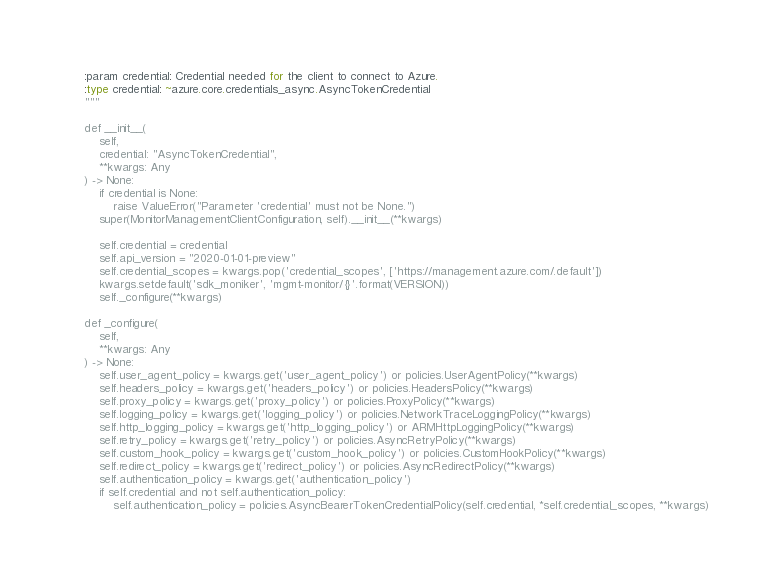<code> <loc_0><loc_0><loc_500><loc_500><_Python_>
    :param credential: Credential needed for the client to connect to Azure.
    :type credential: ~azure.core.credentials_async.AsyncTokenCredential
    """

    def __init__(
        self,
        credential: "AsyncTokenCredential",
        **kwargs: Any
    ) -> None:
        if credential is None:
            raise ValueError("Parameter 'credential' must not be None.")
        super(MonitorManagementClientConfiguration, self).__init__(**kwargs)

        self.credential = credential
        self.api_version = "2020-01-01-preview"
        self.credential_scopes = kwargs.pop('credential_scopes', ['https://management.azure.com/.default'])
        kwargs.setdefault('sdk_moniker', 'mgmt-monitor/{}'.format(VERSION))
        self._configure(**kwargs)

    def _configure(
        self,
        **kwargs: Any
    ) -> None:
        self.user_agent_policy = kwargs.get('user_agent_policy') or policies.UserAgentPolicy(**kwargs)
        self.headers_policy = kwargs.get('headers_policy') or policies.HeadersPolicy(**kwargs)
        self.proxy_policy = kwargs.get('proxy_policy') or policies.ProxyPolicy(**kwargs)
        self.logging_policy = kwargs.get('logging_policy') or policies.NetworkTraceLoggingPolicy(**kwargs)
        self.http_logging_policy = kwargs.get('http_logging_policy') or ARMHttpLoggingPolicy(**kwargs)
        self.retry_policy = kwargs.get('retry_policy') or policies.AsyncRetryPolicy(**kwargs)
        self.custom_hook_policy = kwargs.get('custom_hook_policy') or policies.CustomHookPolicy(**kwargs)
        self.redirect_policy = kwargs.get('redirect_policy') or policies.AsyncRedirectPolicy(**kwargs)
        self.authentication_policy = kwargs.get('authentication_policy')
        if self.credential and not self.authentication_policy:
            self.authentication_policy = policies.AsyncBearerTokenCredentialPolicy(self.credential, *self.credential_scopes, **kwargs)
</code> 